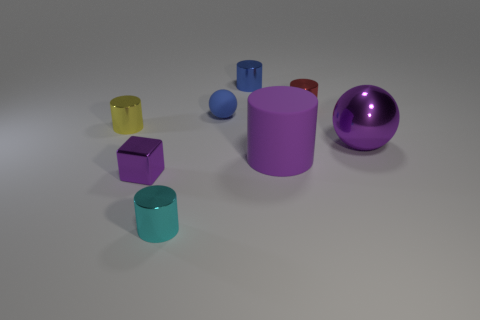There is a big object to the left of the big purple sphere; is its shape the same as the tiny rubber thing?
Provide a short and direct response. No. How many purple matte objects are there?
Give a very brief answer. 1. How many cylinders are the same size as the cyan object?
Provide a short and direct response. 3. What is the yellow cylinder made of?
Provide a short and direct response. Metal. Does the small block have the same color as the large thing that is on the left side of the purple sphere?
Your response must be concise. Yes. Is there any other thing that is the same size as the red metal cylinder?
Provide a succinct answer. Yes. There is a metal thing that is both on the right side of the blue ball and in front of the small matte sphere; what is its size?
Your response must be concise. Large. What shape is the purple object that is the same material as the small ball?
Make the answer very short. Cylinder. Are the purple block and the blue cylinder right of the tiny yellow metallic cylinder made of the same material?
Keep it short and to the point. Yes. Is there a cylinder that is in front of the small metallic cylinder behind the tiny red metallic object?
Provide a succinct answer. Yes. 